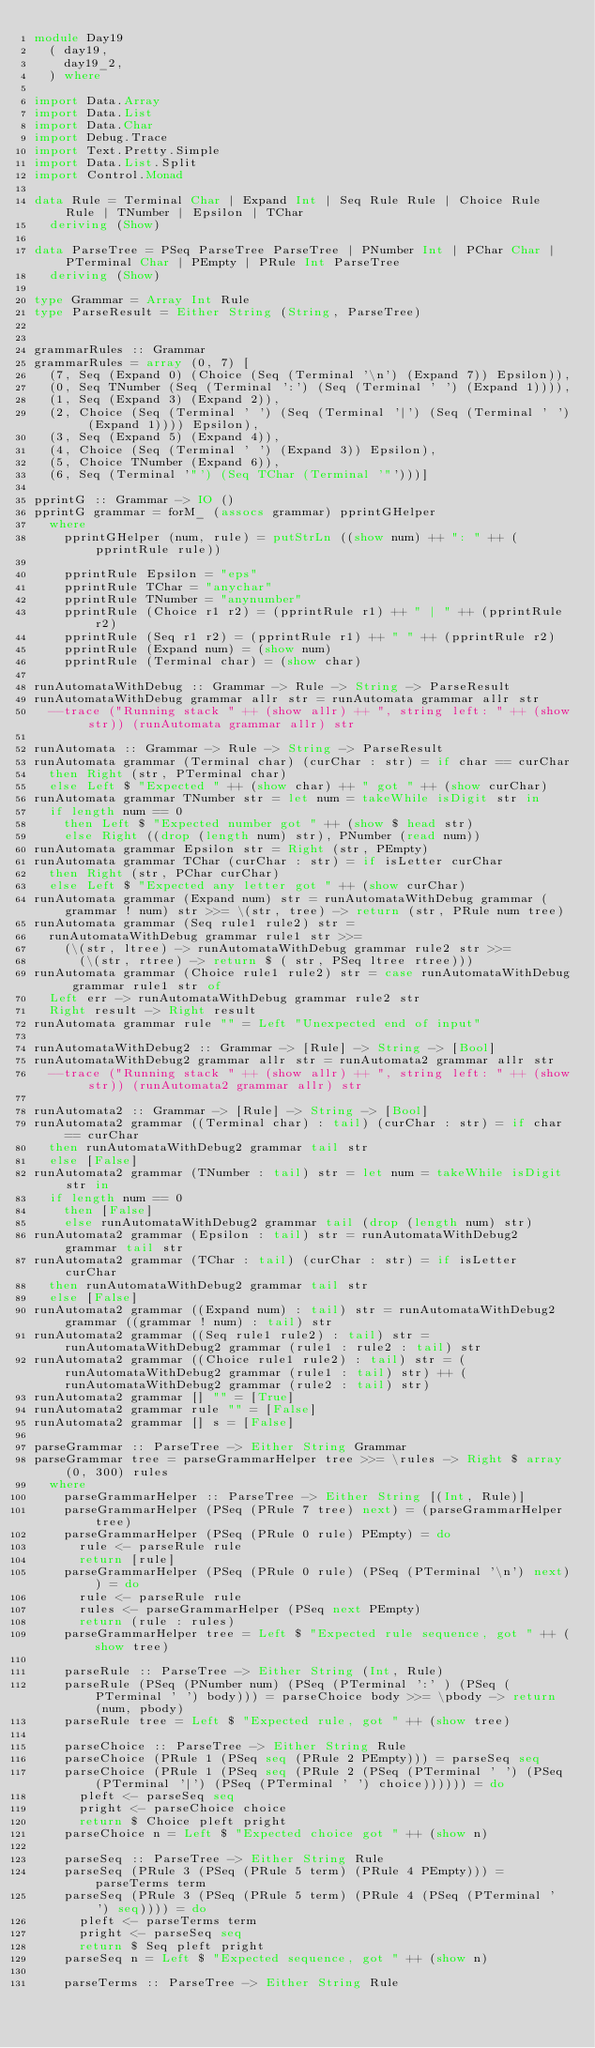Convert code to text. <code><loc_0><loc_0><loc_500><loc_500><_Haskell_>module Day19
  ( day19,
    day19_2,
  ) where

import Data.Array
import Data.List
import Data.Char
import Debug.Trace
import Text.Pretty.Simple
import Data.List.Split
import Control.Monad

data Rule = Terminal Char | Expand Int | Seq Rule Rule | Choice Rule Rule | TNumber | Epsilon | TChar
  deriving (Show)

data ParseTree = PSeq ParseTree ParseTree | PNumber Int | PChar Char | PTerminal Char | PEmpty | PRule Int ParseTree
  deriving (Show)

type Grammar = Array Int Rule
type ParseResult = Either String (String, ParseTree)


grammarRules :: Grammar
grammarRules = array (0, 7) [
  (7, Seq (Expand 0) (Choice (Seq (Terminal '\n') (Expand 7)) Epsilon)),
  (0, Seq TNumber (Seq (Terminal ':') (Seq (Terminal ' ') (Expand 1)))),
  (1, Seq (Expand 3) (Expand 2)),
  (2, Choice (Seq (Terminal ' ') (Seq (Terminal '|') (Seq (Terminal ' ') (Expand 1)))) Epsilon),
  (3, Seq (Expand 5) (Expand 4)),
  (4, Choice (Seq (Terminal ' ') (Expand 3)) Epsilon),
  (5, Choice TNumber (Expand 6)),
  (6, Seq (Terminal '"') (Seq TChar (Terminal '"')))]

pprintG :: Grammar -> IO ()
pprintG grammar = forM_ (assocs grammar) pprintGHelper
  where
    pprintGHelper (num, rule) = putStrLn ((show num) ++ ": " ++ (pprintRule rule))

    pprintRule Epsilon = "eps"
    pprintRule TChar = "anychar"
    pprintRule TNumber = "anynumber"
    pprintRule (Choice r1 r2) = (pprintRule r1) ++ " | " ++ (pprintRule r2)
    pprintRule (Seq r1 r2) = (pprintRule r1) ++ " " ++ (pprintRule r2)
    pprintRule (Expand num) = (show num)
    pprintRule (Terminal char) = (show char)

runAutomataWithDebug :: Grammar -> Rule -> String -> ParseResult
runAutomataWithDebug grammar allr str = runAutomata grammar allr str
  --trace ("Running stack " ++ (show allr) ++ ", string left: " ++ (show str)) (runAutomata grammar allr) str

runAutomata :: Grammar -> Rule -> String -> ParseResult
runAutomata grammar (Terminal char) (curChar : str) = if char == curChar
  then Right (str, PTerminal char)
  else Left $ "Expected " ++ (show char) ++ " got " ++ (show curChar)
runAutomata grammar TNumber str = let num = takeWhile isDigit str in
  if length num == 0
    then Left $ "Expected number got " ++ (show $ head str)
    else Right ((drop (length num) str), PNumber (read num))
runAutomata grammar Epsilon str = Right (str, PEmpty)
runAutomata grammar TChar (curChar : str) = if isLetter curChar
  then Right (str, PChar curChar)
  else Left $ "Expected any letter got " ++ (show curChar)
runAutomata grammar (Expand num) str = runAutomataWithDebug grammar (grammar ! num) str >>= \(str, tree) -> return (str, PRule num tree)
runAutomata grammar (Seq rule1 rule2) str =
  runAutomataWithDebug grammar rule1 str >>=
    (\(str, ltree) -> runAutomataWithDebug grammar rule2 str >>=
      (\(str, rtree) -> return $ ( str, PSeq ltree rtree)))
runAutomata grammar (Choice rule1 rule2) str = case runAutomataWithDebug grammar rule1 str of
  Left err -> runAutomataWithDebug grammar rule2 str
  Right result -> Right result
runAutomata grammar rule "" = Left "Unexpected end of input"

runAutomataWithDebug2 :: Grammar -> [Rule] -> String -> [Bool]
runAutomataWithDebug2 grammar allr str = runAutomata2 grammar allr str
  --trace ("Running stack " ++ (show allr) ++ ", string left: " ++ (show str)) (runAutomata2 grammar allr) str

runAutomata2 :: Grammar -> [Rule] -> String -> [Bool]
runAutomata2 grammar ((Terminal char) : tail) (curChar : str) = if char == curChar
  then runAutomataWithDebug2 grammar tail str
  else [False]
runAutomata2 grammar (TNumber : tail) str = let num = takeWhile isDigit str in
  if length num == 0
    then [False]
    else runAutomataWithDebug2 grammar tail (drop (length num) str)
runAutomata2 grammar (Epsilon : tail) str = runAutomataWithDebug2 grammar tail str
runAutomata2 grammar (TChar : tail) (curChar : str) = if isLetter curChar
  then runAutomataWithDebug2 grammar tail str
  else [False]
runAutomata2 grammar ((Expand num) : tail) str = runAutomataWithDebug2 grammar ((grammar ! num) : tail) str
runAutomata2 grammar ((Seq rule1 rule2) : tail) str = runAutomataWithDebug2 grammar (rule1 : rule2 : tail) str
runAutomata2 grammar ((Choice rule1 rule2) : tail) str = (runAutomataWithDebug2 grammar (rule1 : tail) str) ++ (runAutomataWithDebug2 grammar (rule2 : tail) str)
runAutomata2 grammar [] "" = [True]
runAutomata2 grammar rule "" = [False]
runAutomata2 grammar [] s = [False]

parseGrammar :: ParseTree -> Either String Grammar
parseGrammar tree = parseGrammarHelper tree >>= \rules -> Right $ array (0, 300) rules
  where
    parseGrammarHelper :: ParseTree -> Either String [(Int, Rule)]
    parseGrammarHelper (PSeq (PRule 7 tree) next) = (parseGrammarHelper tree)
    parseGrammarHelper (PSeq (PRule 0 rule) PEmpty) = do
      rule <- parseRule rule
      return [rule]
    parseGrammarHelper (PSeq (PRule 0 rule) (PSeq (PTerminal '\n') next)) = do
      rule <- parseRule rule
      rules <- parseGrammarHelper (PSeq next PEmpty)
      return (rule : rules)
    parseGrammarHelper tree = Left $ "Expected rule sequence, got " ++ (show tree)

    parseRule :: ParseTree -> Either String (Int, Rule)
    parseRule (PSeq (PNumber num) (PSeq (PTerminal ':' ) (PSeq (PTerminal ' ') body))) = parseChoice body >>= \pbody -> return (num, pbody)
    parseRule tree = Left $ "Expected rule, got " ++ (show tree)

    parseChoice :: ParseTree -> Either String Rule
    parseChoice (PRule 1 (PSeq seq (PRule 2 PEmpty))) = parseSeq seq
    parseChoice (PRule 1 (PSeq seq (PRule 2 (PSeq (PTerminal ' ') (PSeq (PTerminal '|') (PSeq (PTerminal ' ') choice)))))) = do
      pleft <- parseSeq seq
      pright <- parseChoice choice
      return $ Choice pleft pright
    parseChoice n = Left $ "Expected choice got " ++ (show n)

    parseSeq :: ParseTree -> Either String Rule
    parseSeq (PRule 3 (PSeq (PRule 5 term) (PRule 4 PEmpty))) = parseTerms term
    parseSeq (PRule 3 (PSeq (PRule 5 term) (PRule 4 (PSeq (PTerminal ' ') seq)))) = do
      pleft <- parseTerms term
      pright <- parseSeq seq
      return $ Seq pleft pright
    parseSeq n = Left $ "Expected sequence, got " ++ (show n)

    parseTerms :: ParseTree -> Either String Rule</code> 